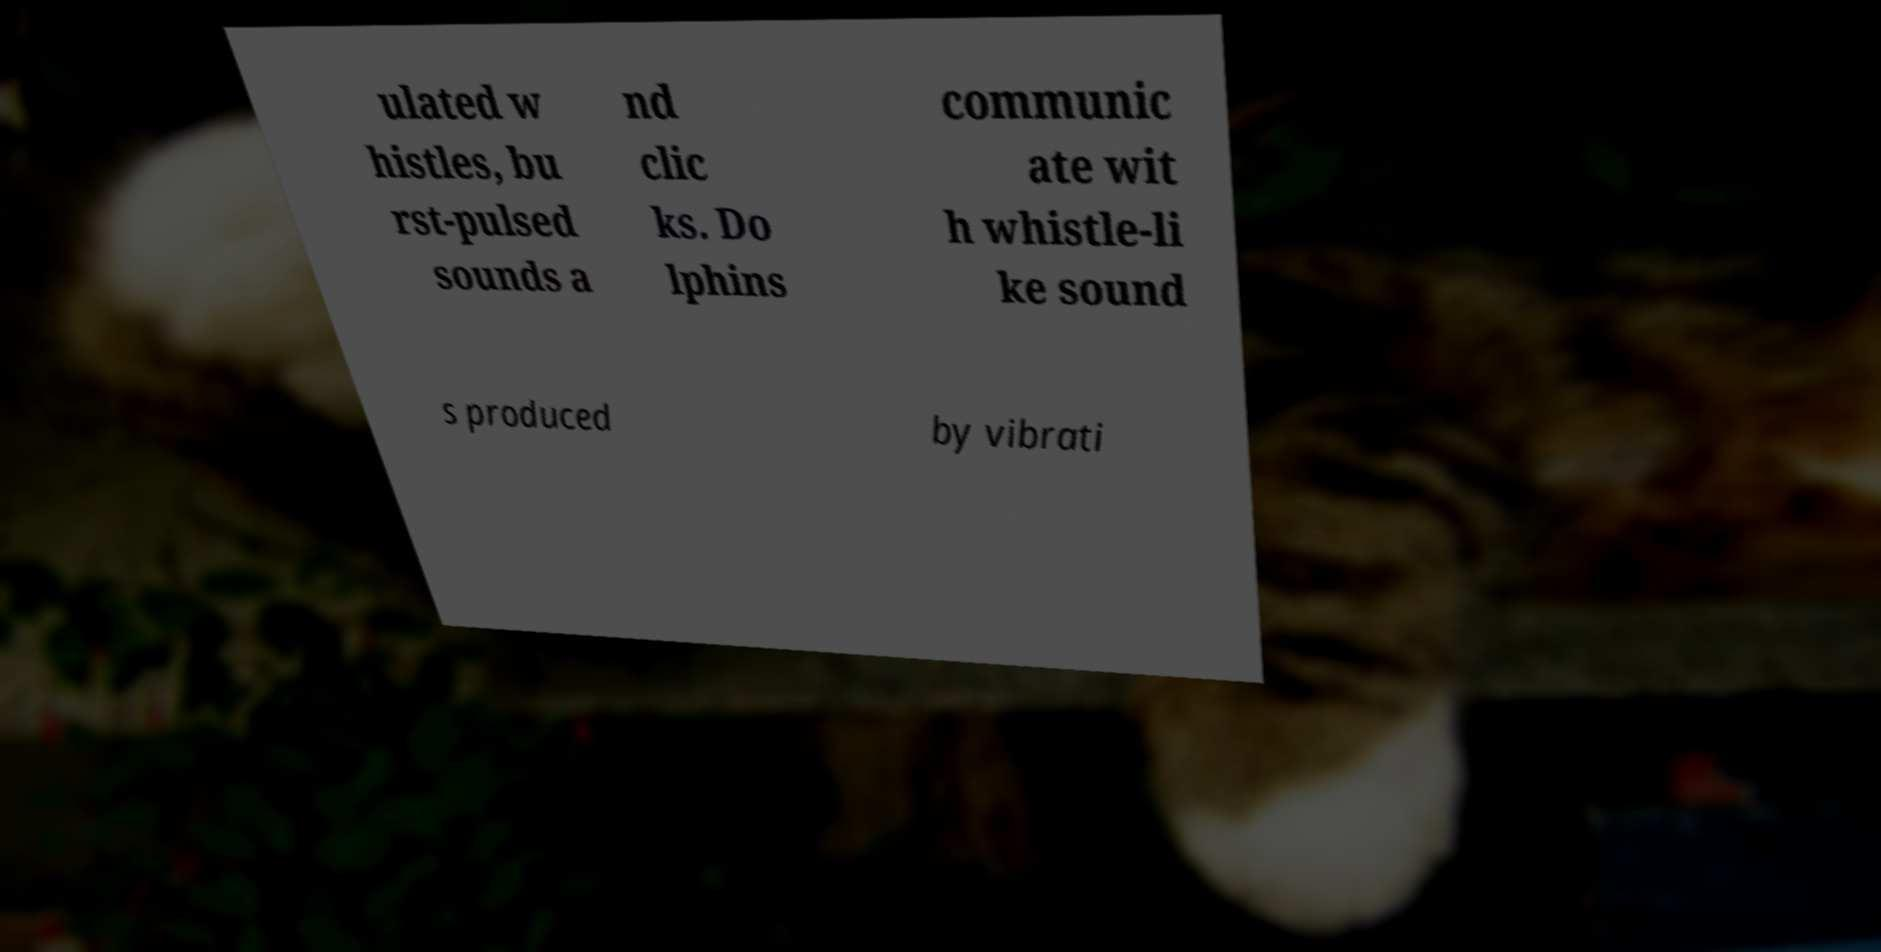What messages or text are displayed in this image? I need them in a readable, typed format. ulated w histles, bu rst-pulsed sounds a nd clic ks. Do lphins communic ate wit h whistle-li ke sound s produced by vibrati 